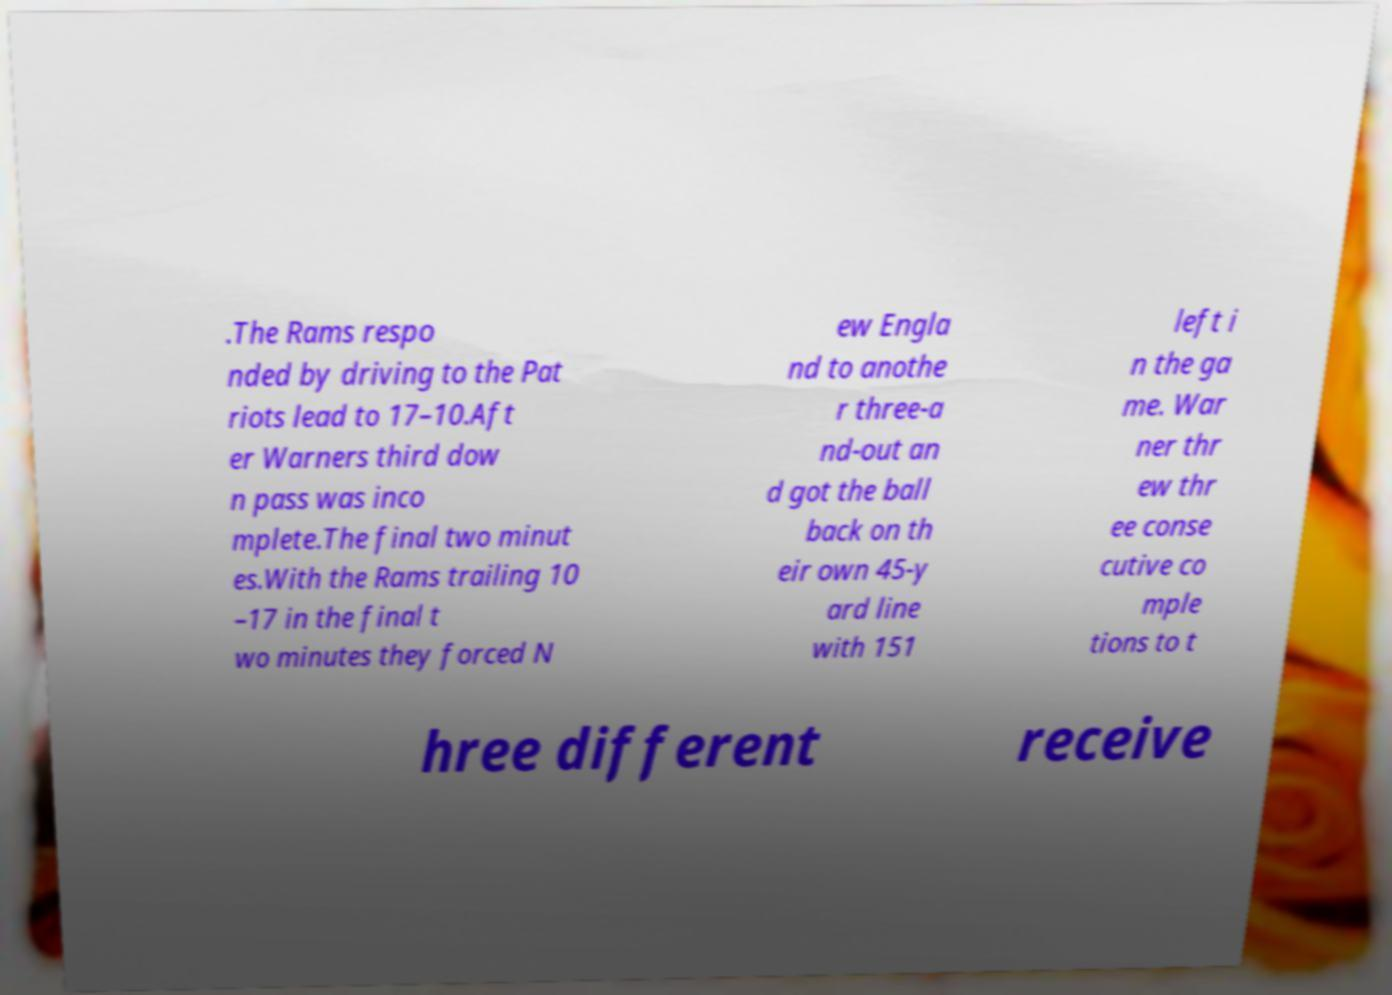Please identify and transcribe the text found in this image. .The Rams respo nded by driving to the Pat riots lead to 17–10.Aft er Warners third dow n pass was inco mplete.The final two minut es.With the Rams trailing 10 –17 in the final t wo minutes they forced N ew Engla nd to anothe r three-a nd-out an d got the ball back on th eir own 45-y ard line with 151 left i n the ga me. War ner thr ew thr ee conse cutive co mple tions to t hree different receive 